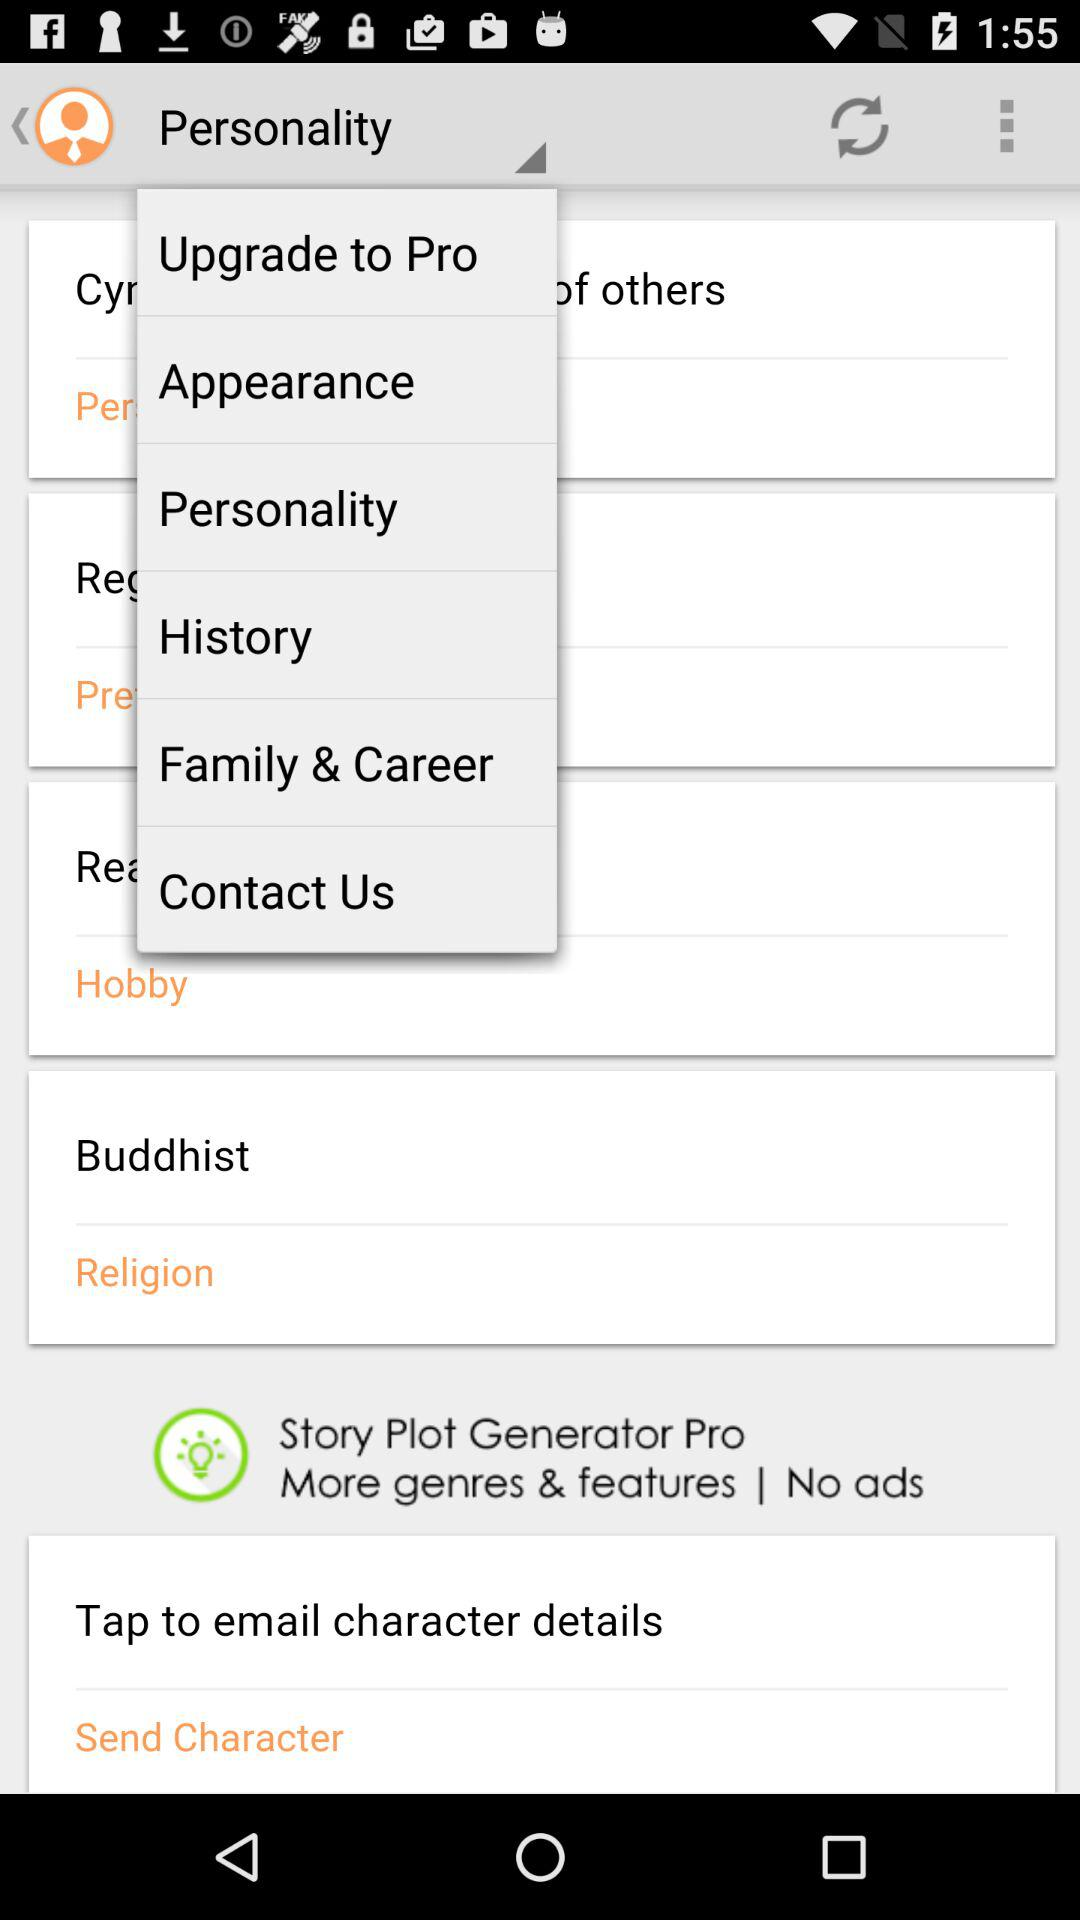What is the religion? The religion is Buddhist. 